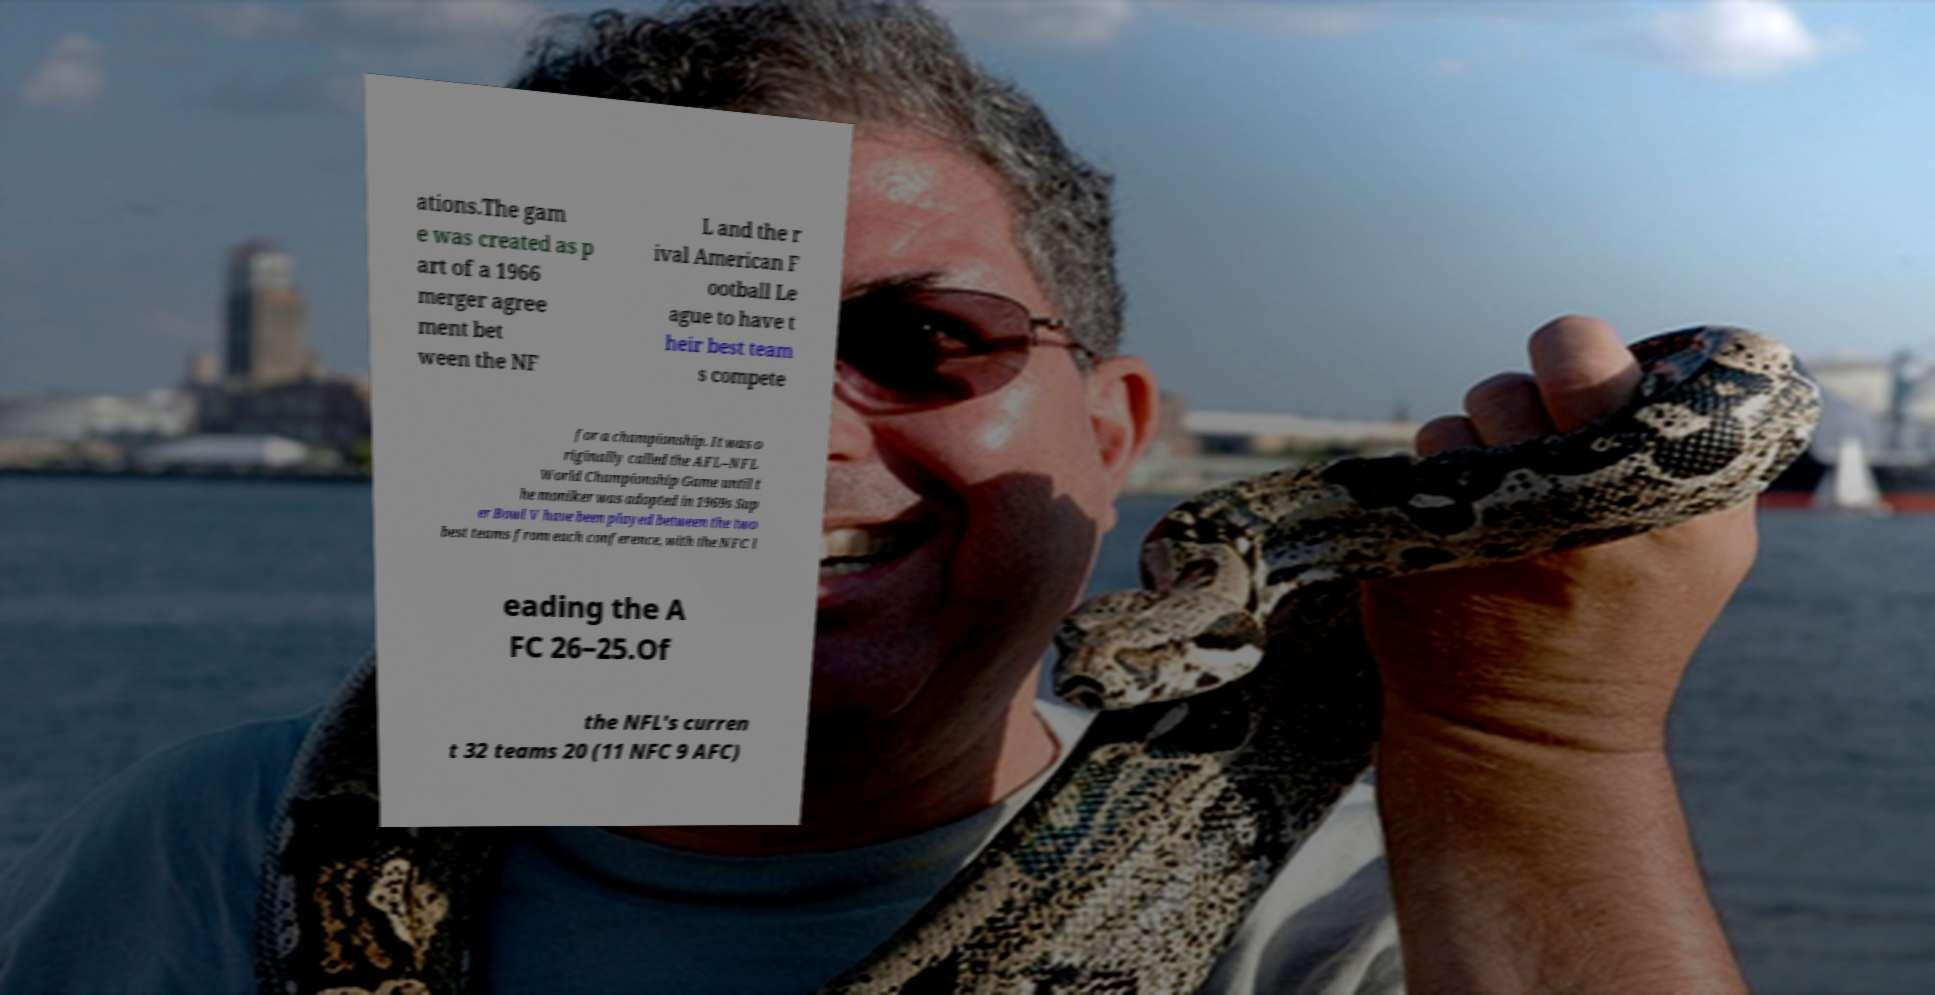Can you read and provide the text displayed in the image?This photo seems to have some interesting text. Can you extract and type it out for me? ations.The gam e was created as p art of a 1966 merger agree ment bet ween the NF L and the r ival American F ootball Le ague to have t heir best team s compete for a championship. It was o riginally called the AFL–NFL World Championship Game until t he moniker was adopted in 1969s Sup er Bowl V have been played between the two best teams from each conference, with the NFC l eading the A FC 26–25.Of the NFL's curren t 32 teams 20 (11 NFC 9 AFC) 